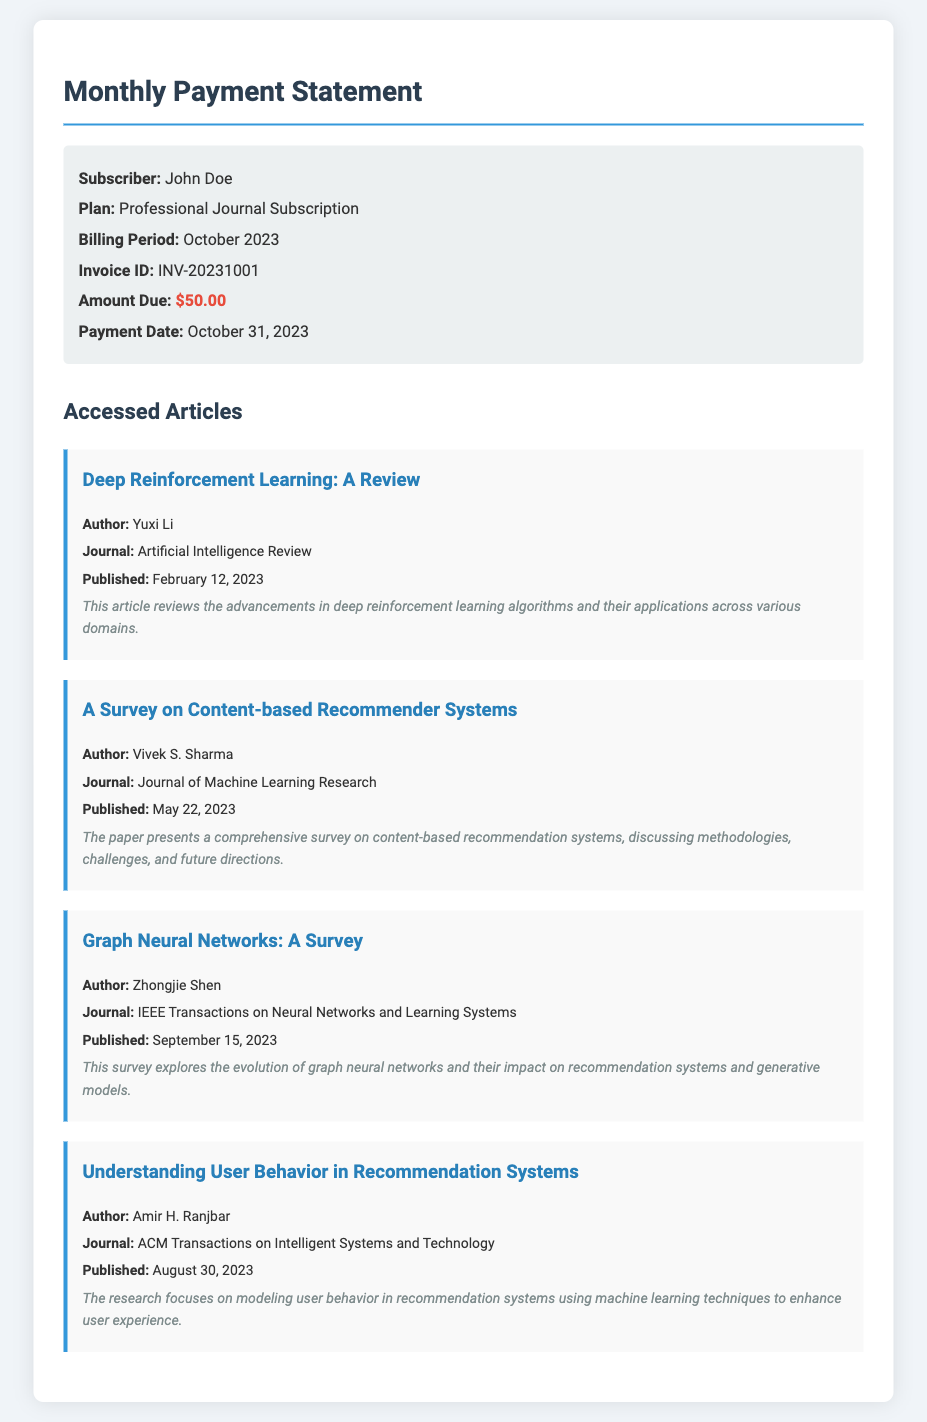What is the billing period for the subscription? The billing period is explicitly mentioned in the document as October 2023.
Answer: October 2023 Who is the author of "Graph Neural Networks: A Survey"? The document lists Zhongjie Shen as the author of this article.
Answer: Zhongjie Shen What was the amount due for the subscription? The document states that the amount due is $50.00.
Answer: $50.00 When was the payment date? The payment date is mentioned in the document as October 31, 2023.
Answer: October 31, 2023 Which journal published the article on user behavior in recommendation systems? The document specifies that the article was published in ACM Transactions on Intelligent Systems and Technology.
Answer: ACM Transactions on Intelligent Systems and Technology How many articles were accessed in October 2023? The document lists four articles under the accessed articles section.
Answer: Four What is the main focus of the article by Amir H. Ranjbar? The focus of the article is on modeling user behavior in recommendation systems using machine learning techniques.
Answer: Modeling user behavior Which subscription plan does John Doe have? The document clearly states John Doe has a Professional Journal Subscription.
Answer: Professional Journal Subscription What is the invoice ID for the transaction? The document specifies the invoice ID as INV-20231001.
Answer: INV-20231001 